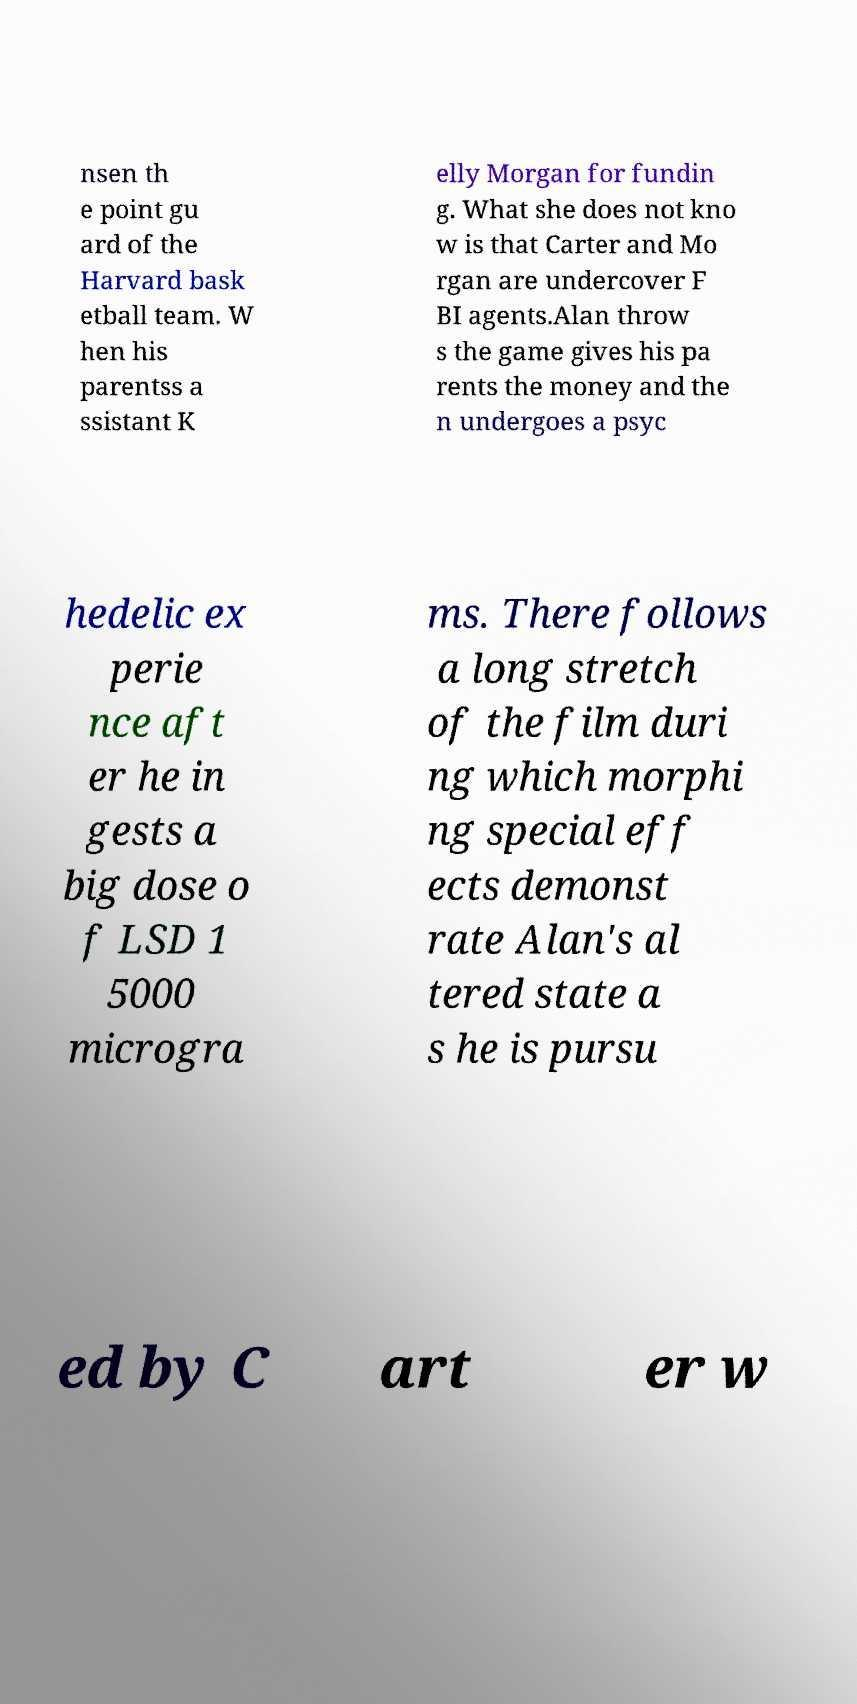What messages or text are displayed in this image? I need them in a readable, typed format. nsen th e point gu ard of the Harvard bask etball team. W hen his parentss a ssistant K elly Morgan for fundin g. What she does not kno w is that Carter and Mo rgan are undercover F BI agents.Alan throw s the game gives his pa rents the money and the n undergoes a psyc hedelic ex perie nce aft er he in gests a big dose o f LSD 1 5000 microgra ms. There follows a long stretch of the film duri ng which morphi ng special eff ects demonst rate Alan's al tered state a s he is pursu ed by C art er w 